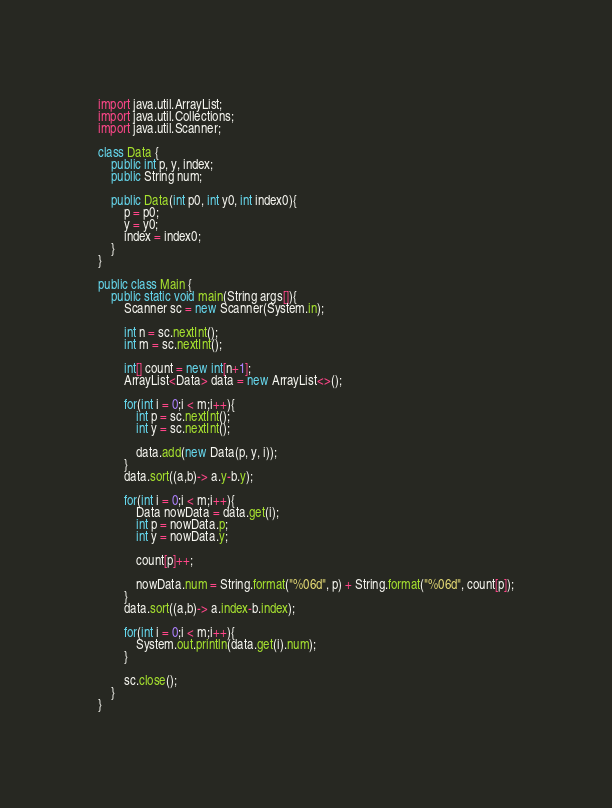Convert code to text. <code><loc_0><loc_0><loc_500><loc_500><_Java_>import java.util.ArrayList;
import java.util.Collections;
import java.util.Scanner;

class Data {
	public int p, y, index;
	public String num;

	public Data(int p0, int y0, int index0){
		p = p0;
		y = y0;
		index = index0;
	}
}

public class Main {
	public static void main(String args[]){
		Scanner sc = new Scanner(System.in);

		int n = sc.nextInt();
		int m = sc.nextInt();
		
		int[] count = new int[n+1];
		ArrayList<Data> data = new ArrayList<>();
		
		for(int i = 0;i < m;i++){
			int p = sc.nextInt();
			int y = sc.nextInt();
			
			data.add(new Data(p, y, i));
		}
		data.sort((a,b)-> a.y-b.y);
		
		for(int i = 0;i < m;i++){
			Data nowData = data.get(i);
			int p = nowData.p;
			int y = nowData.y;
			
			count[p]++;
			
			nowData.num = String.format("%06d", p) + String.format("%06d", count[p]);
		}
		data.sort((a,b)-> a.index-b.index);
		
		for(int i = 0;i < m;i++){
			System.out.println(data.get(i).num);
		}
		
		sc.close();
	}
}</code> 